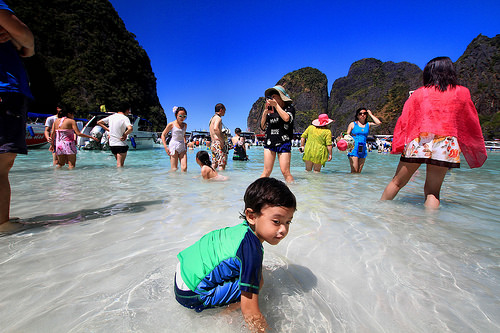<image>
Can you confirm if the blue swimsuit is on the lady? No. The blue swimsuit is not positioned on the lady. They may be near each other, but the blue swimsuit is not supported by or resting on top of the lady. Where is the woman in relation to the water? Is it in the water? Yes. The woman is contained within or inside the water, showing a containment relationship. 